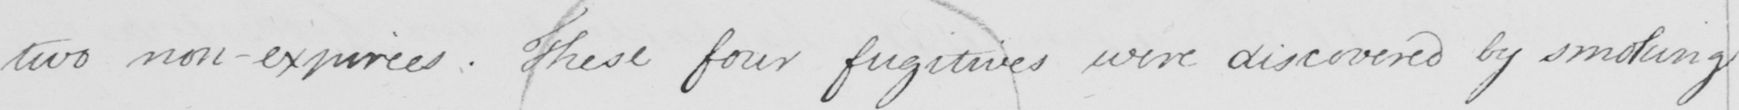What text is written in this handwritten line? two non-expirees . These four fugitives were discovered by smoking 